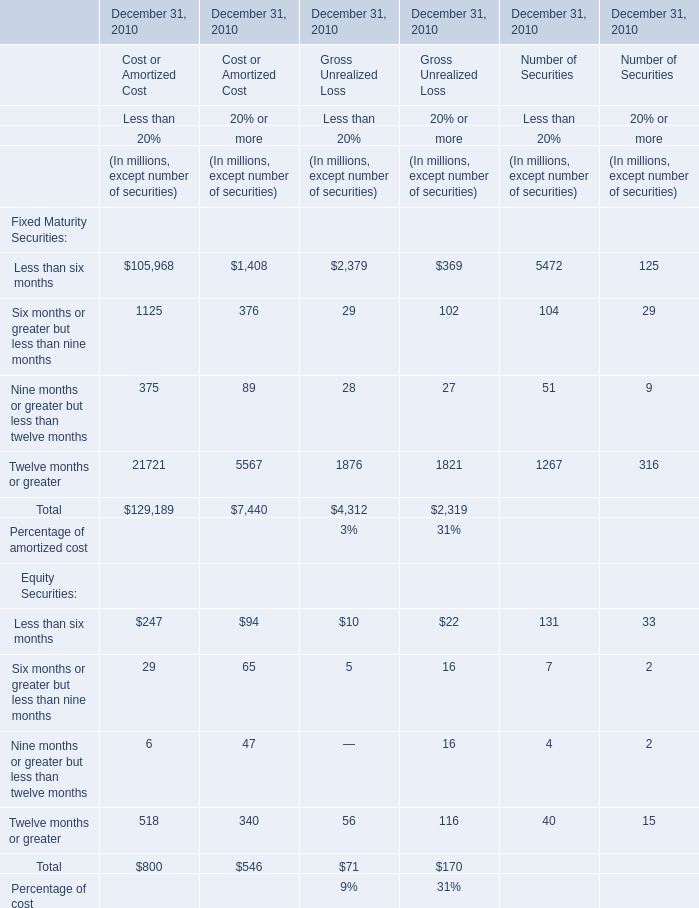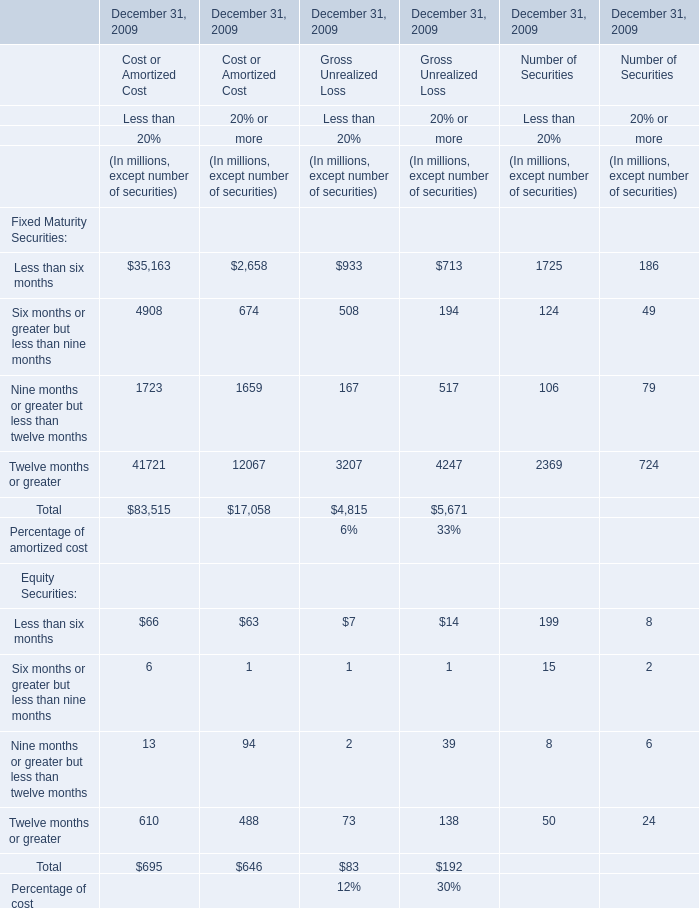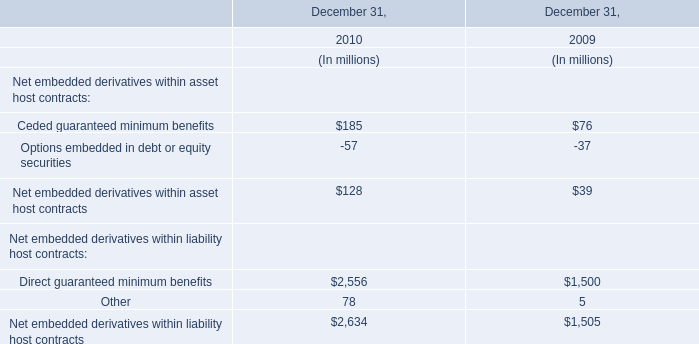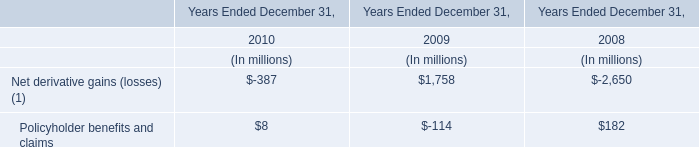What was the total amount of elements excluding those elements greater than 10000 for Cost or Amortized Cost of Less than 20% ? (in million) 
Computations: (((((4908 + 1723) + 66) + 6) + 13) + 610)
Answer: 7326.0. 